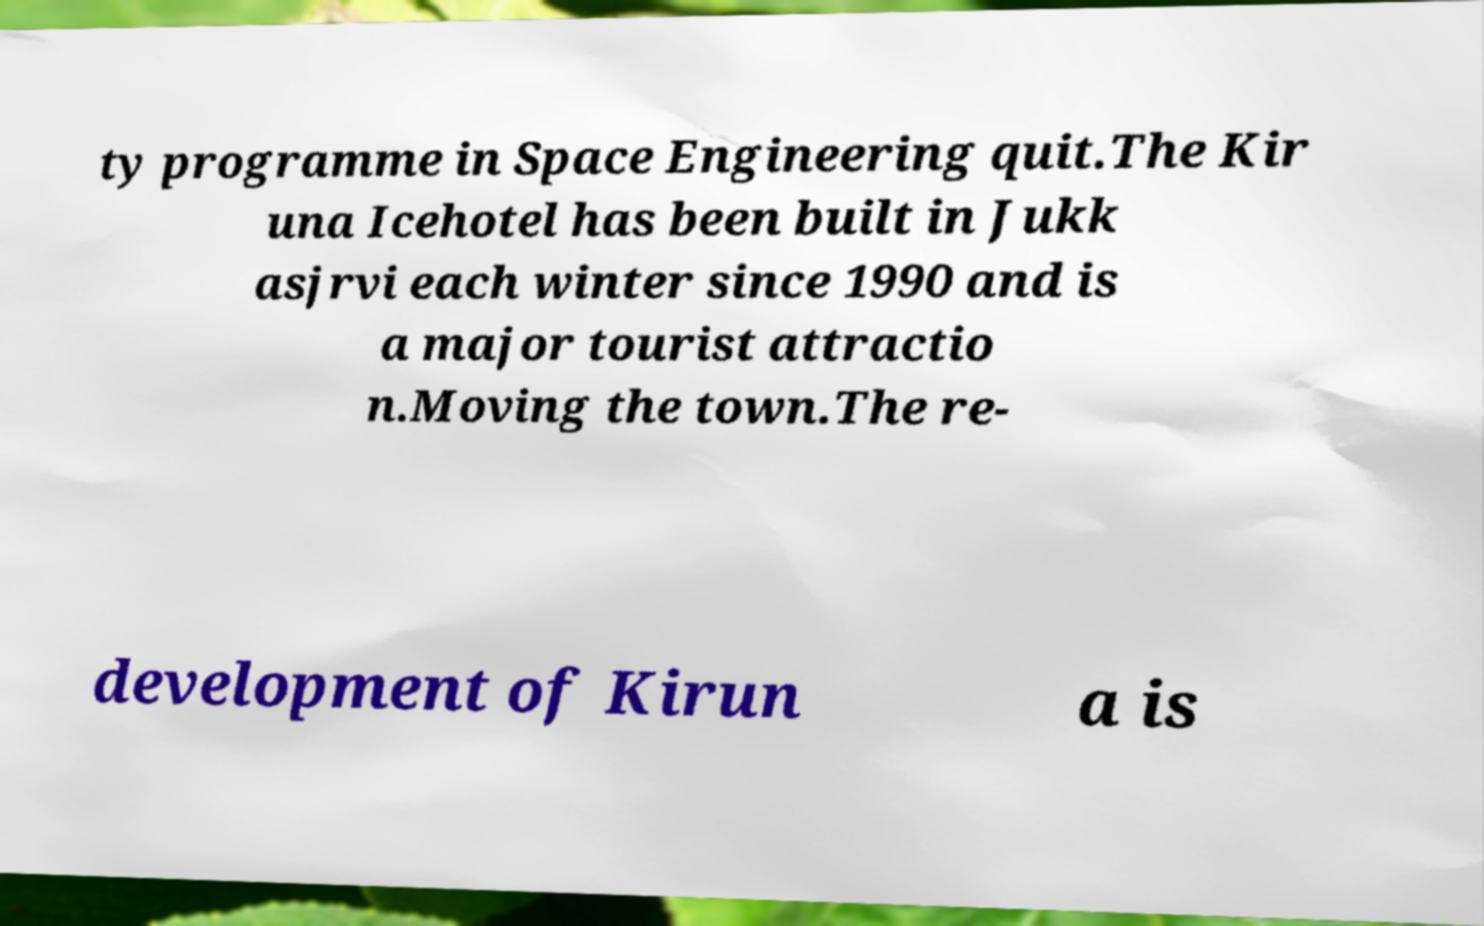Please identify and transcribe the text found in this image. ty programme in Space Engineering quit.The Kir una Icehotel has been built in Jukk asjrvi each winter since 1990 and is a major tourist attractio n.Moving the town.The re- development of Kirun a is 